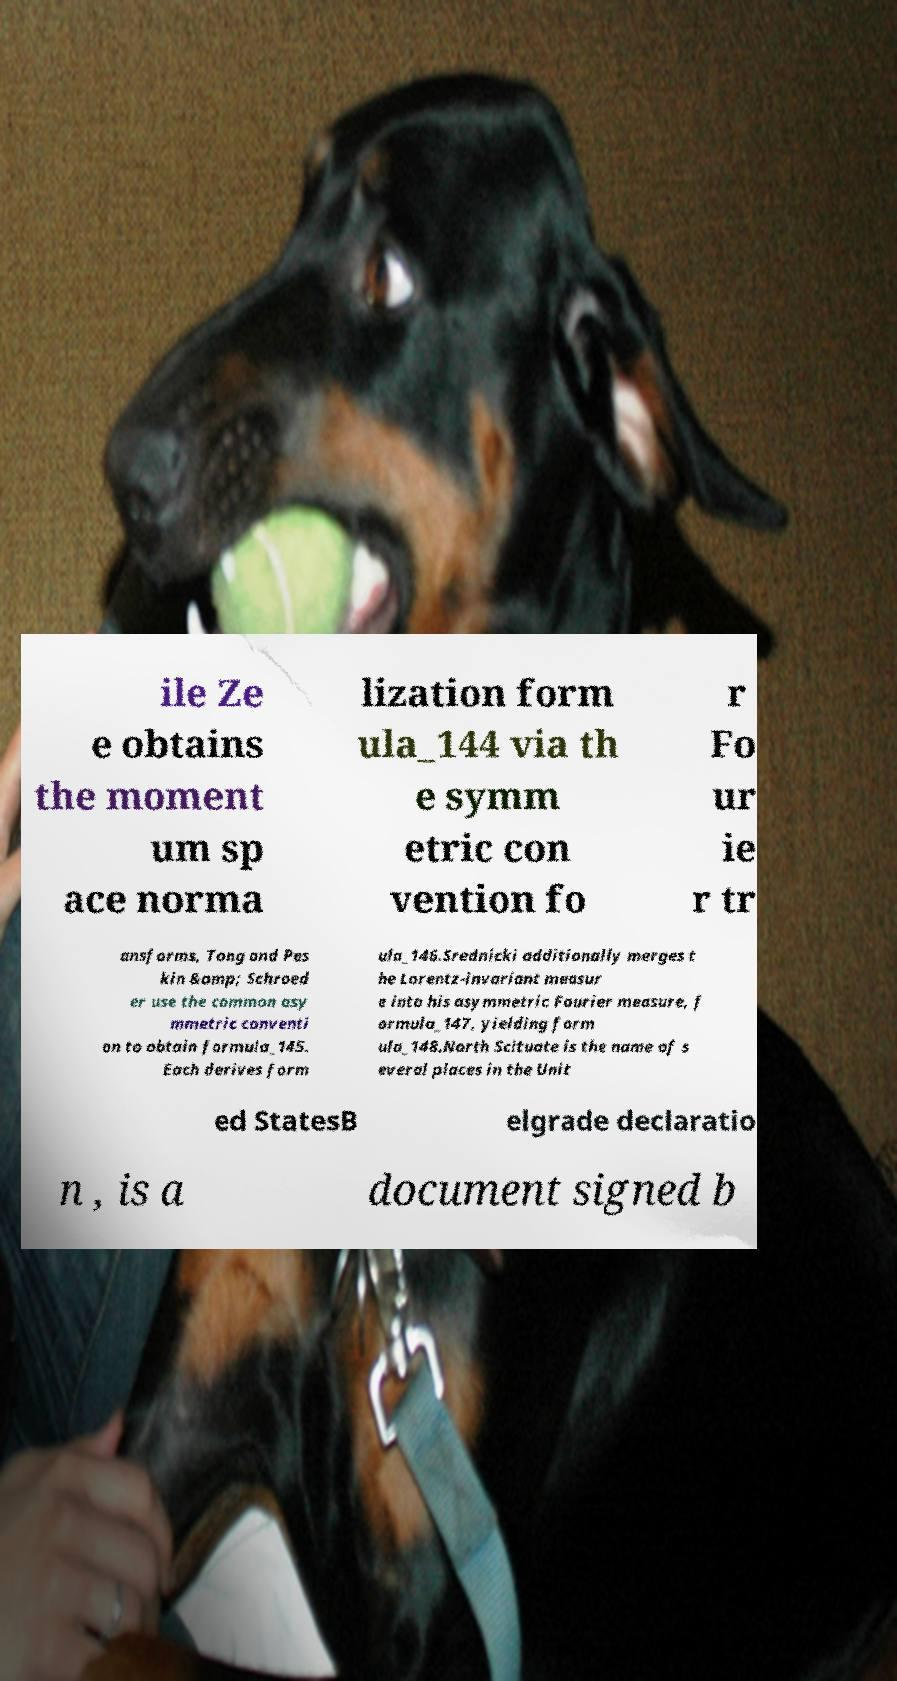Could you extract and type out the text from this image? ile Ze e obtains the moment um sp ace norma lization form ula_144 via th e symm etric con vention fo r Fo ur ie r tr ansforms, Tong and Pes kin &amp; Schroed er use the common asy mmetric conventi on to obtain formula_145. Each derives form ula_146.Srednicki additionally merges t he Lorentz-invariant measur e into his asymmetric Fourier measure, f ormula_147, yielding form ula_148.North Scituate is the name of s everal places in the Unit ed StatesB elgrade declaratio n , is a document signed b 